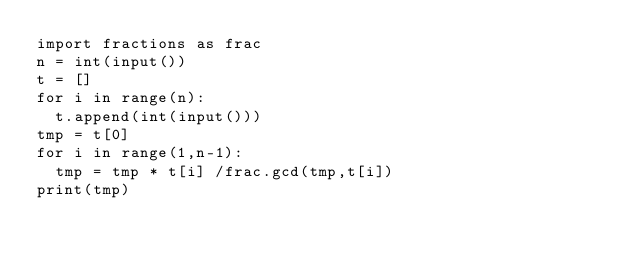Convert code to text. <code><loc_0><loc_0><loc_500><loc_500><_Python_>import fractions as frac
n = int(input())
t = []
for i in range(n):
  t.append(int(input()))
tmp = t[0]
for i in range(1,n-1):
	tmp = tmp * t[i] /frac.gcd(tmp,t[i]) 
print(tmp)</code> 